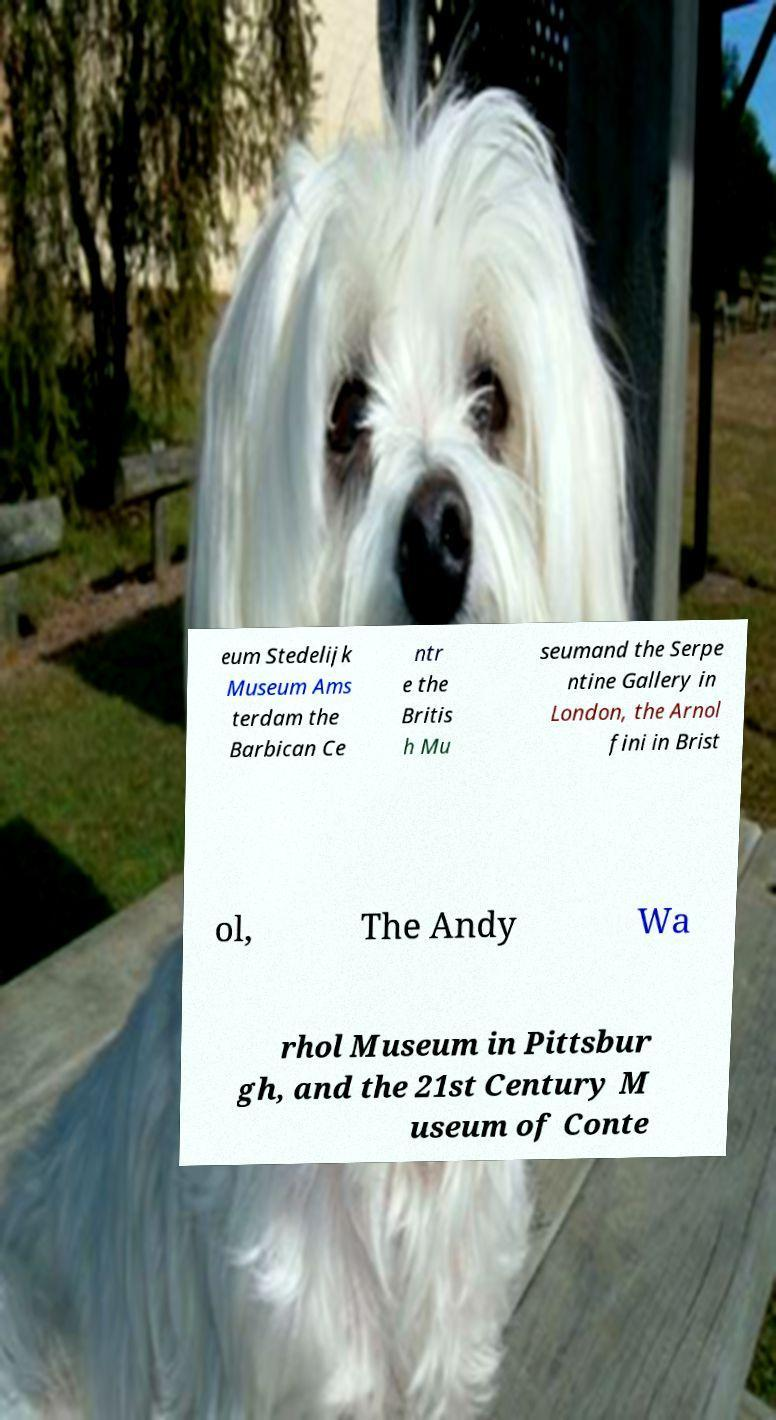Please read and relay the text visible in this image. What does it say? eum Stedelijk Museum Ams terdam the Barbican Ce ntr e the Britis h Mu seumand the Serpe ntine Gallery in London, the Arnol fini in Brist ol, The Andy Wa rhol Museum in Pittsbur gh, and the 21st Century M useum of Conte 